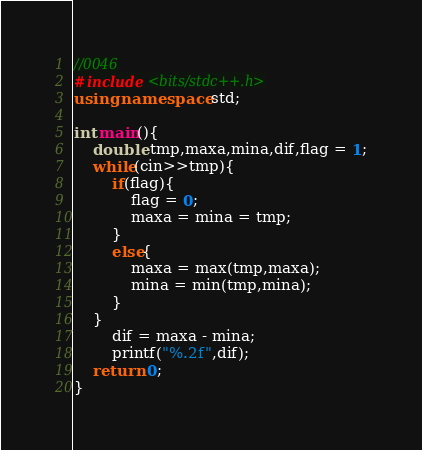Convert code to text. <code><loc_0><loc_0><loc_500><loc_500><_C++_>//0046
#include <bits/stdc++.h>
using namespace std;

int main(){
	double tmp,maxa,mina,dif,flag = 1;
	while(cin>>tmp){
		if(flag){
			flag = 0;
			maxa = mina = tmp;
		}
		else{
			maxa = max(tmp,maxa);
			mina = min(tmp,mina);
		}
	}
		dif = maxa - mina;
		printf("%.2f",dif);
	return 0;
}</code> 